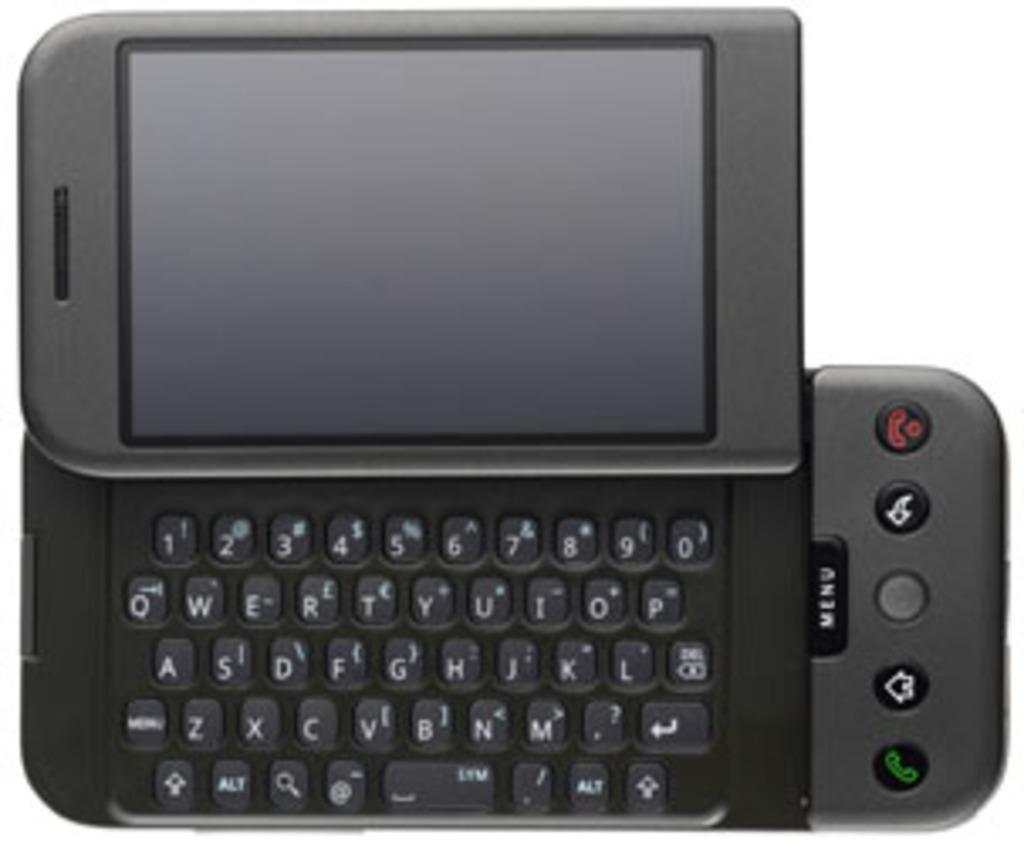Provide a one-sentence caption for the provided image. A small mobile device with a black menu button. 